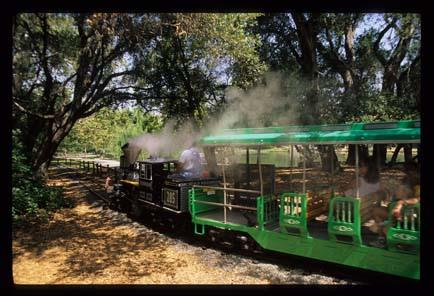What food is the same color as the largest portion of this vehicle? Please explain your reasoning. spinach. Spinach is green in color. 